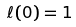Convert formula to latex. <formula><loc_0><loc_0><loc_500><loc_500>\ell ( 0 ) = 1</formula> 